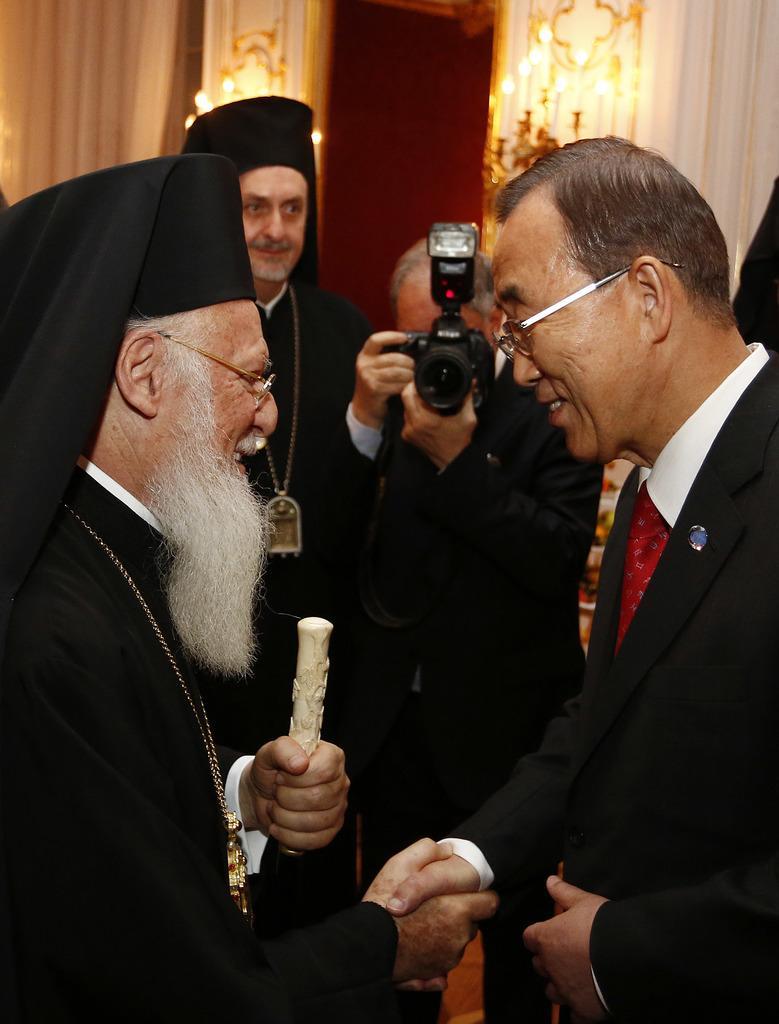Could you give a brief overview of what you see in this image? In this picture we can see group of people, two persons are greeting each other, and one person is capturing the photo with camera, in the background we can see couple of lights and curtains. 